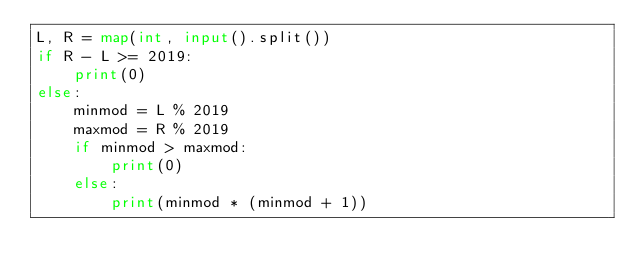<code> <loc_0><loc_0><loc_500><loc_500><_Python_>L, R = map(int, input().split())
if R - L >= 2019:
    print(0)
else:
    minmod = L % 2019
    maxmod = R % 2019
    if minmod > maxmod:
        print(0)
    else:
        print(minmod * (minmod + 1))</code> 